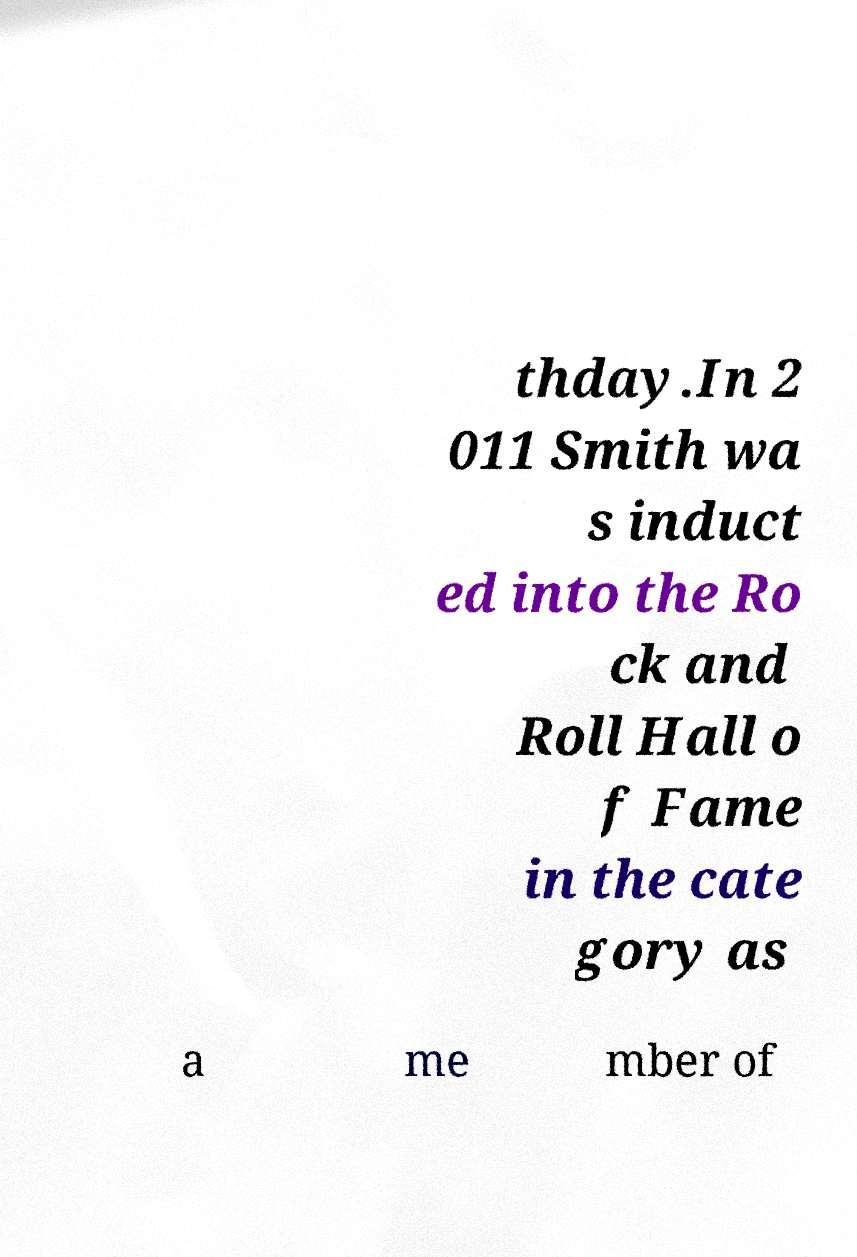Can you read and provide the text displayed in the image?This photo seems to have some interesting text. Can you extract and type it out for me? thday.In 2 011 Smith wa s induct ed into the Ro ck and Roll Hall o f Fame in the cate gory as a me mber of 